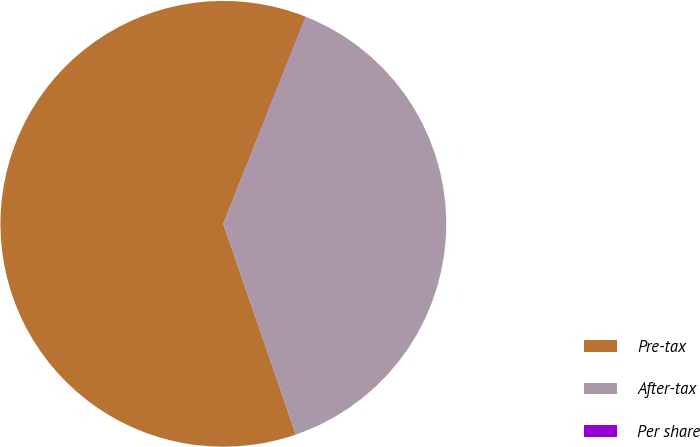Convert chart. <chart><loc_0><loc_0><loc_500><loc_500><pie_chart><fcel>Pre-tax<fcel>After-tax<fcel>Per share<nl><fcel>61.28%<fcel>38.69%<fcel>0.02%<nl></chart> 